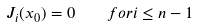<formula> <loc_0><loc_0><loc_500><loc_500>J _ { i } ( x _ { 0 } ) = 0 \quad f o r i \leq n - 1</formula> 